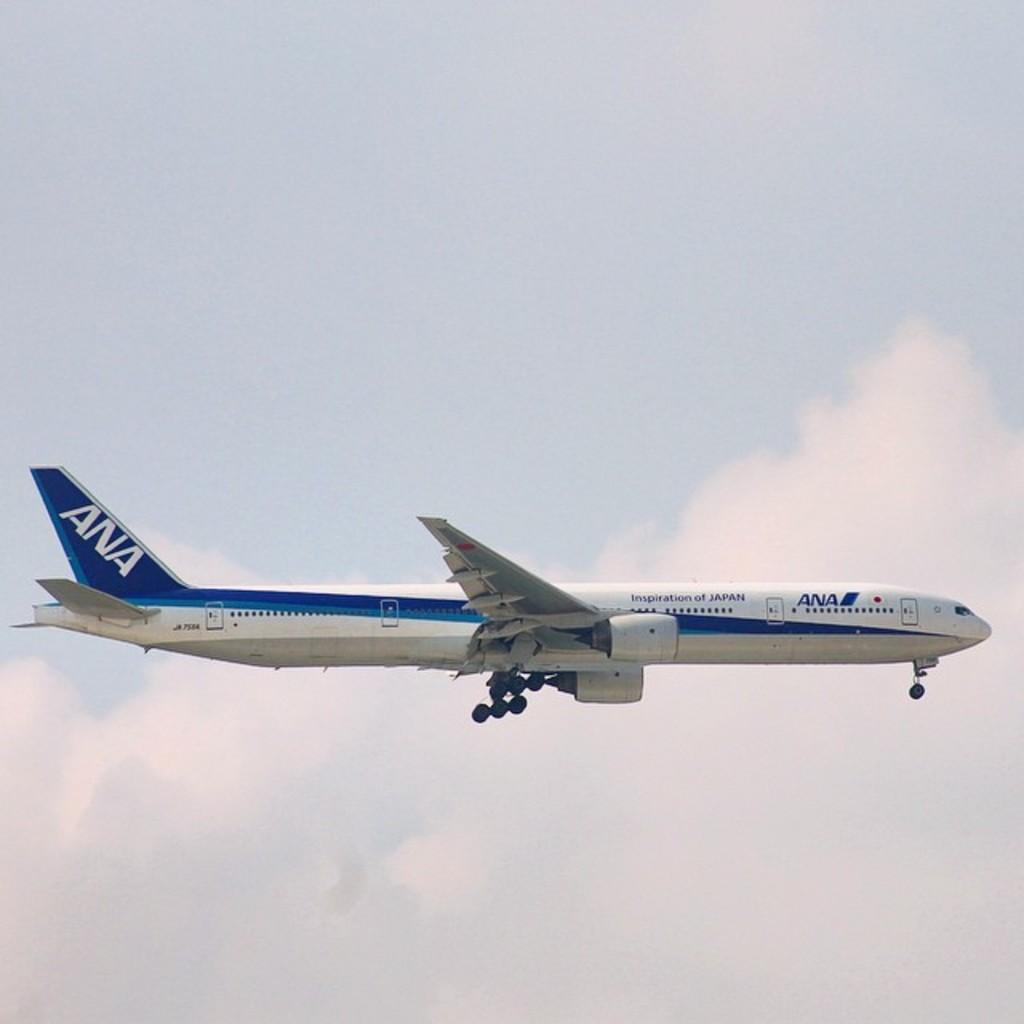Provide a one-sentence caption for the provided image. Ana plane is blue and white in flying in the sky. 